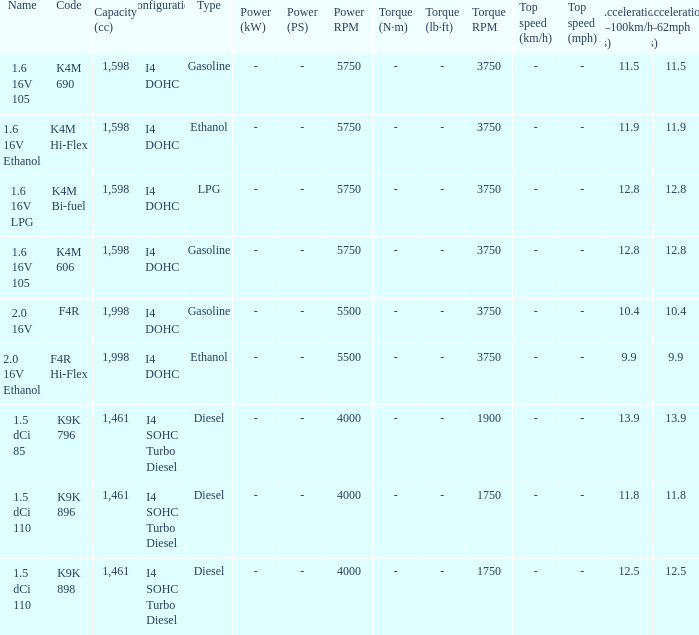What is the code of 1.5 dci 110, which has a capacity of 1,461cc? K9K 896, K9K 898. 